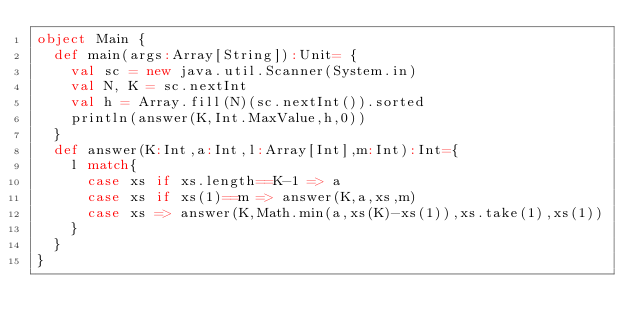Convert code to text. <code><loc_0><loc_0><loc_500><loc_500><_Scala_>object Main {
  def main(args:Array[String]):Unit= {
    val sc = new java.util.Scanner(System.in)
    val N, K = sc.nextInt
    val h = Array.fill(N)(sc.nextInt()).sorted
    println(answer(K,Int.MaxValue,h,0))
  }
  def answer(K:Int,a:Int,l:Array[Int],m:Int):Int={
    l match{
      case xs if xs.length==K-1 => a
      case xs if xs(1)==m => answer(K,a,xs,m)
      case xs => answer(K,Math.min(a,xs(K)-xs(1)),xs.take(1),xs(1))
    }
  }
}</code> 